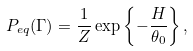Convert formula to latex. <formula><loc_0><loc_0><loc_500><loc_500>P _ { e q } ( { \Gamma } ) = \frac { 1 } { Z } \exp \left \{ - \frac { H } { \theta _ { 0 } } \right \} ,</formula> 